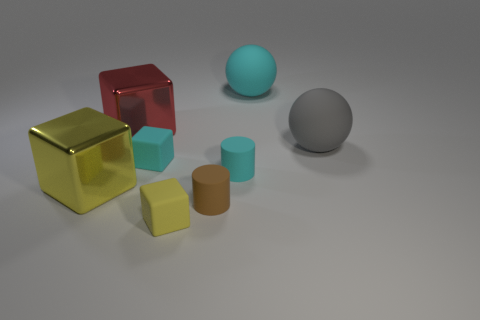How does the lighting affect the appearance of these objects? The lighting in this scene appears to be soft and diffused, coming from an overhead source, which gives the objects gentle shadows and subtle highlights. This emphasizes their shapes and gives a three-dimensional quality to the image. The reflective surfaces of the spheres and the golden cube are particularly impacted, showcasing bright reflections that draw the eye and hint at the texture of the surfaces—shiny for the spheres and metallic for the gold cube. 